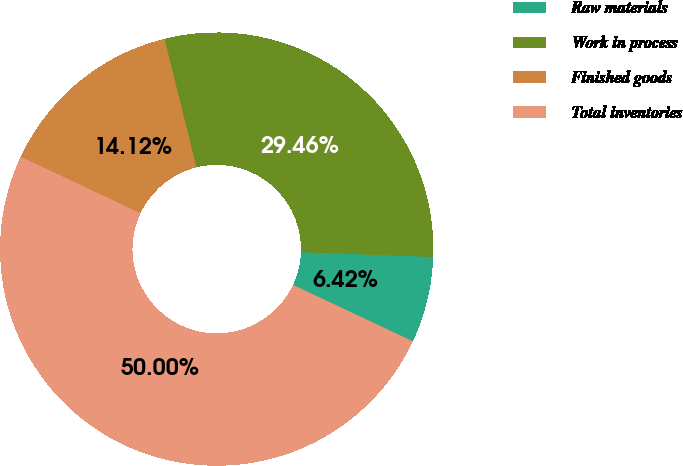<chart> <loc_0><loc_0><loc_500><loc_500><pie_chart><fcel>Raw materials<fcel>Work in process<fcel>Finished goods<fcel>Total inventories<nl><fcel>6.42%<fcel>29.46%<fcel>14.12%<fcel>50.0%<nl></chart> 